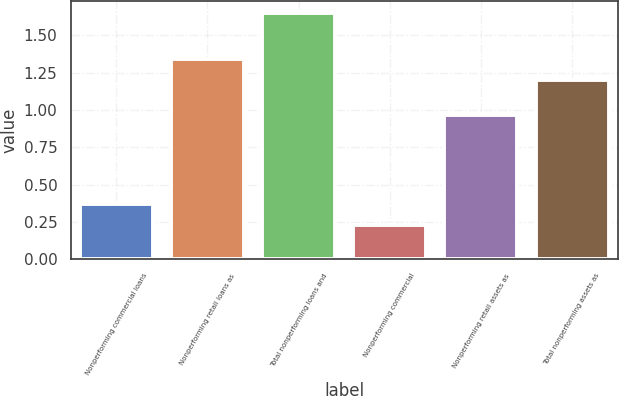Convert chart to OTSL. <chart><loc_0><loc_0><loc_500><loc_500><bar_chart><fcel>Nonperforming commercial loans<fcel>Nonperforming retail loans as<fcel>Total nonperforming loans and<fcel>Nonperforming commercial<fcel>Nonperforming retail assets as<fcel>Total nonperforming assets as<nl><fcel>0.37<fcel>1.34<fcel>1.65<fcel>0.23<fcel>0.97<fcel>1.2<nl></chart> 